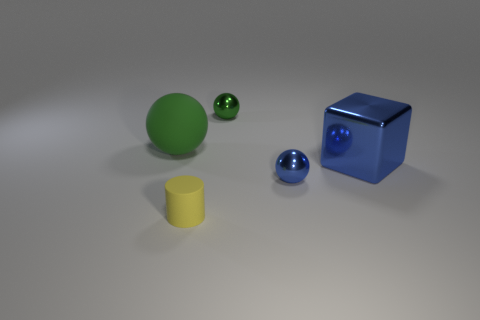Add 5 large green things. How many objects exist? 10 Subtract all cylinders. How many objects are left? 4 Subtract 0 blue cylinders. How many objects are left? 5 Subtract all tiny purple cylinders. Subtract all large spheres. How many objects are left? 4 Add 5 tiny yellow cylinders. How many tiny yellow cylinders are left? 6 Add 2 green matte spheres. How many green matte spheres exist? 3 